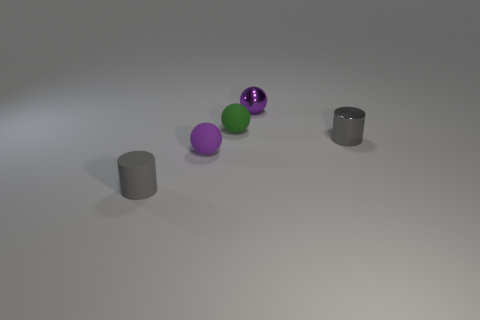Add 3 tiny gray rubber cylinders. How many objects exist? 8 Subtract all balls. How many objects are left? 2 Subtract all gray cylinders. Subtract all tiny cylinders. How many objects are left? 1 Add 5 green rubber objects. How many green rubber objects are left? 6 Add 3 purple shiny blocks. How many purple shiny blocks exist? 3 Subtract 0 brown blocks. How many objects are left? 5 